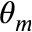Convert formula to latex. <formula><loc_0><loc_0><loc_500><loc_500>\theta _ { m }</formula> 